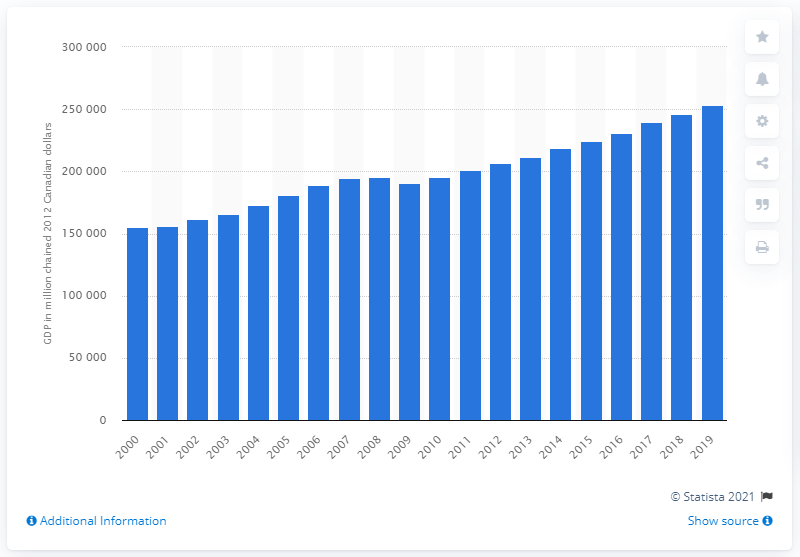Give some essential details in this illustration. In 2019, the Gross Domestic Product (GDP) of British Columbia was approximately 253,048.7 